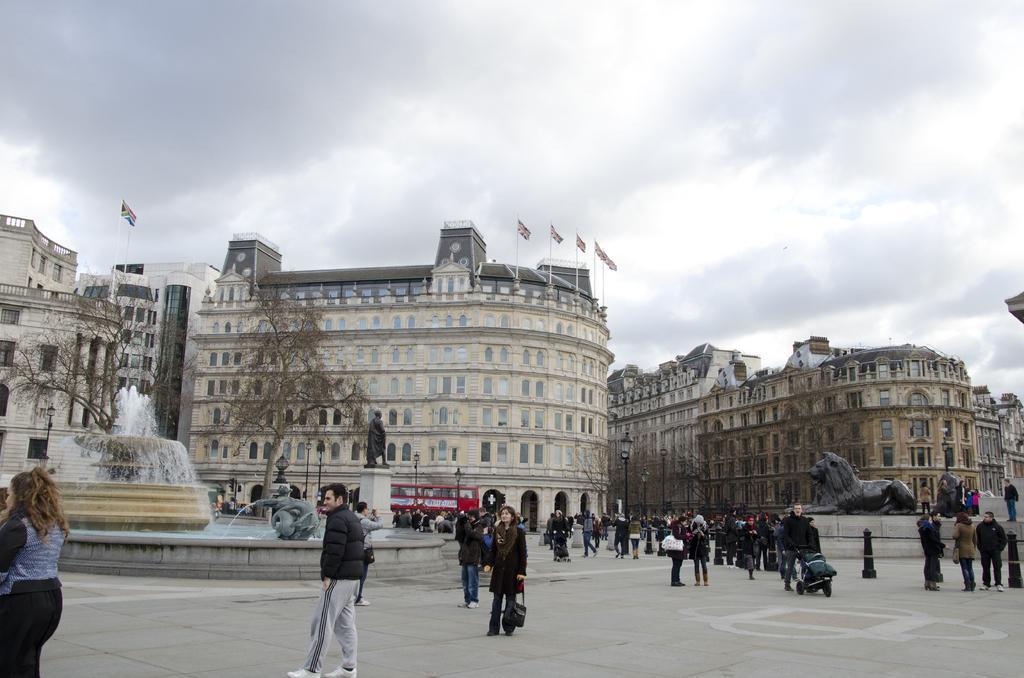Please provide a concise description of this image. In the image there is a pavement and there are a lot of people standing and walking on the pavement, there is a fountain on the left side and on the right side there is a sculpture, in the background there are buildings. 